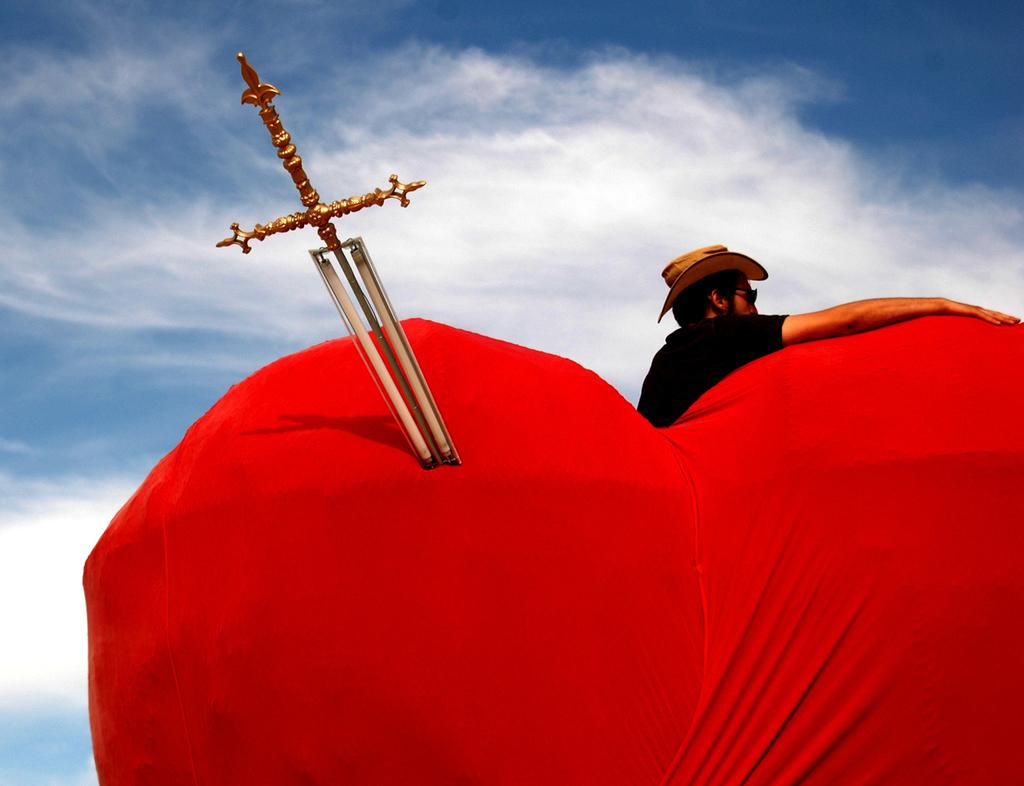What object can be seen in the image that is typically associated with combat or battles? There is a sword in the image. Who is present in the image? There is a man in the image. What shape and color is the object that appears to be related to love or affection? The object is heart-shaped and red in color. What type of education is being offered in the image? There is no indication of any educational activity or subject in the image. 